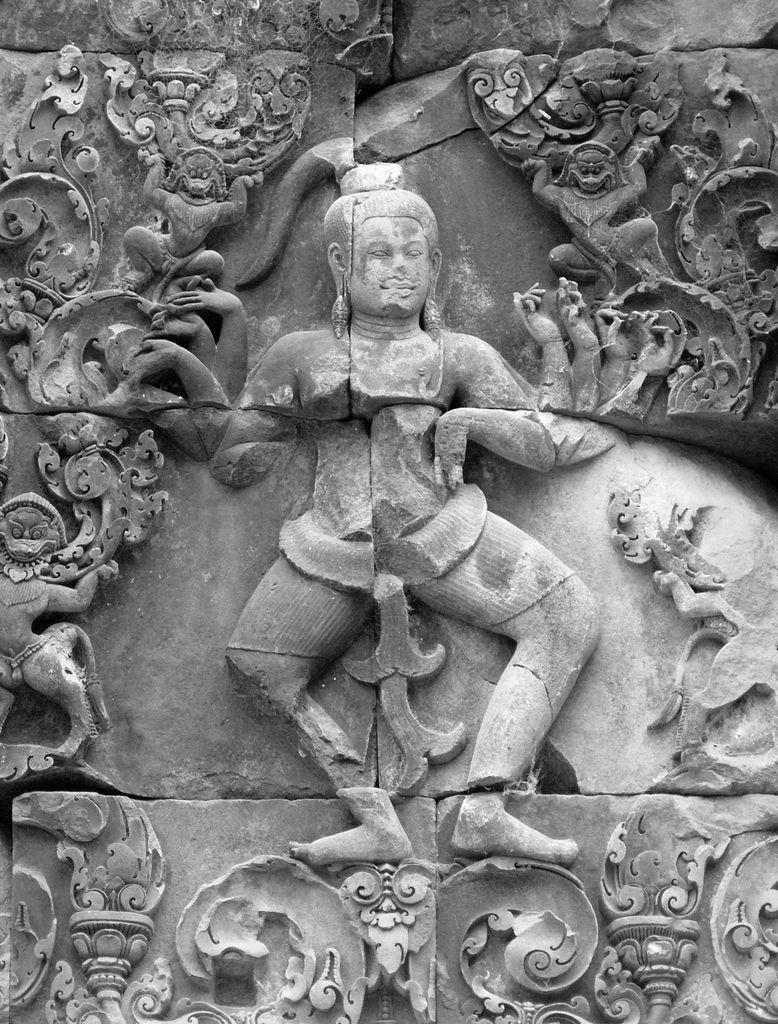How would you summarize this image in a sentence or two? In this picture I see the sculptures which are of white and grey in color. 